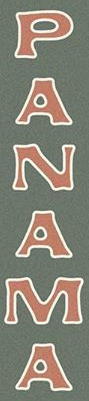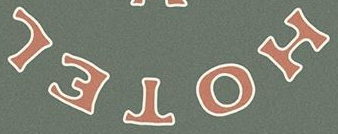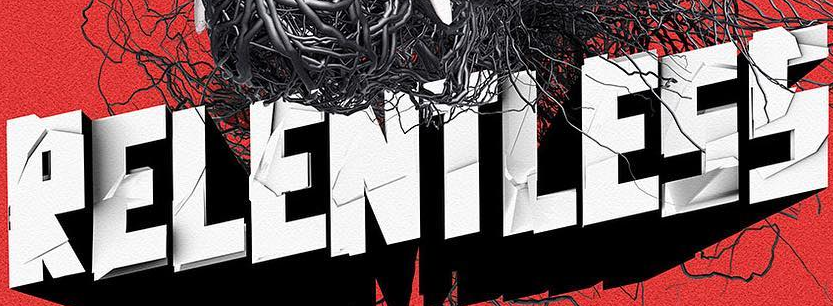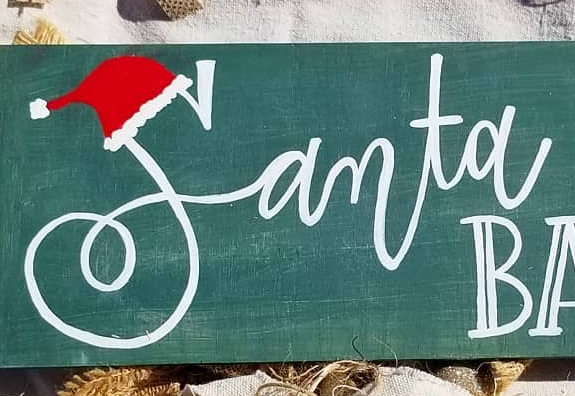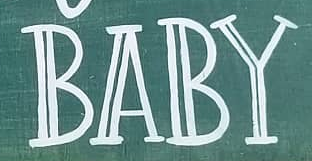Transcribe the words shown in these images in order, separated by a semicolon. PANAMA; HOTEL; RELENTLESS; Samta; BABY 